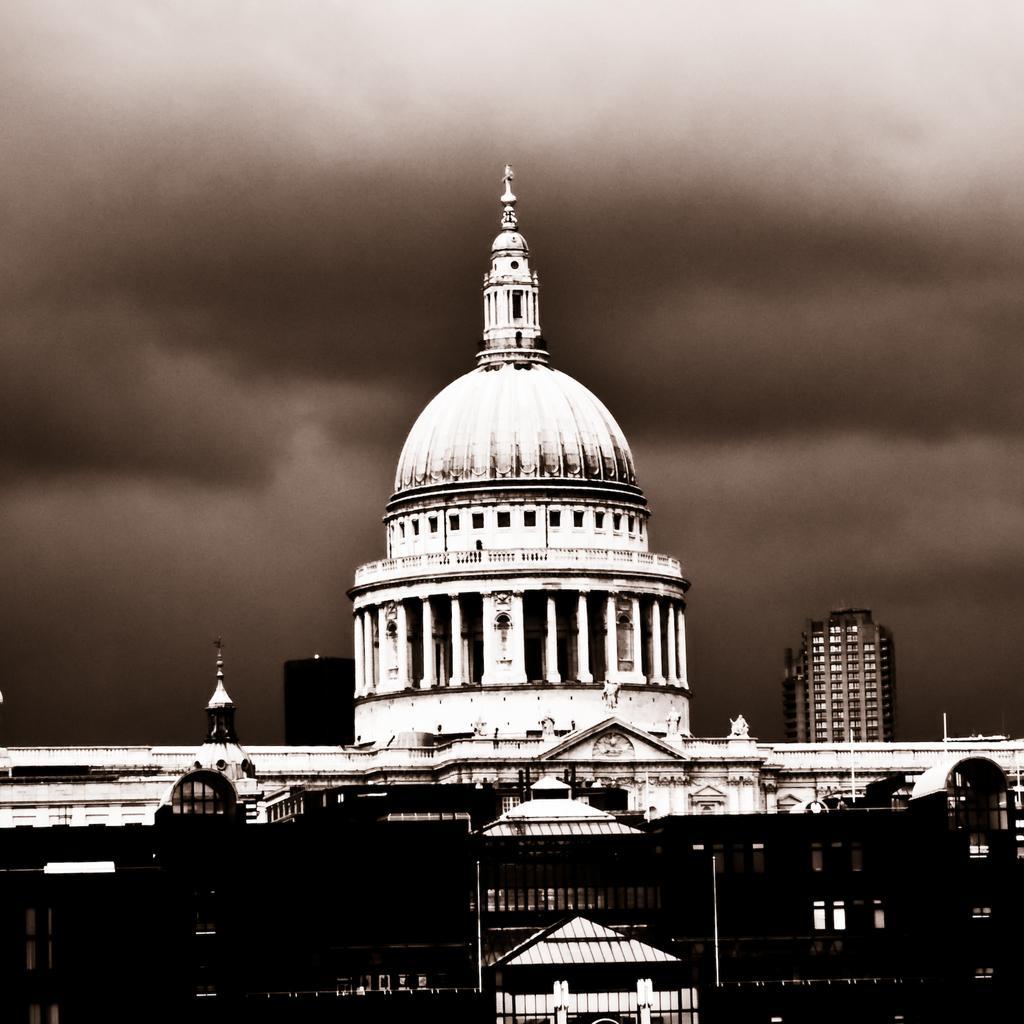Please provide a concise description of this image. In this picture we can see buildings. In the background of the image we can see the sky with clouds. 